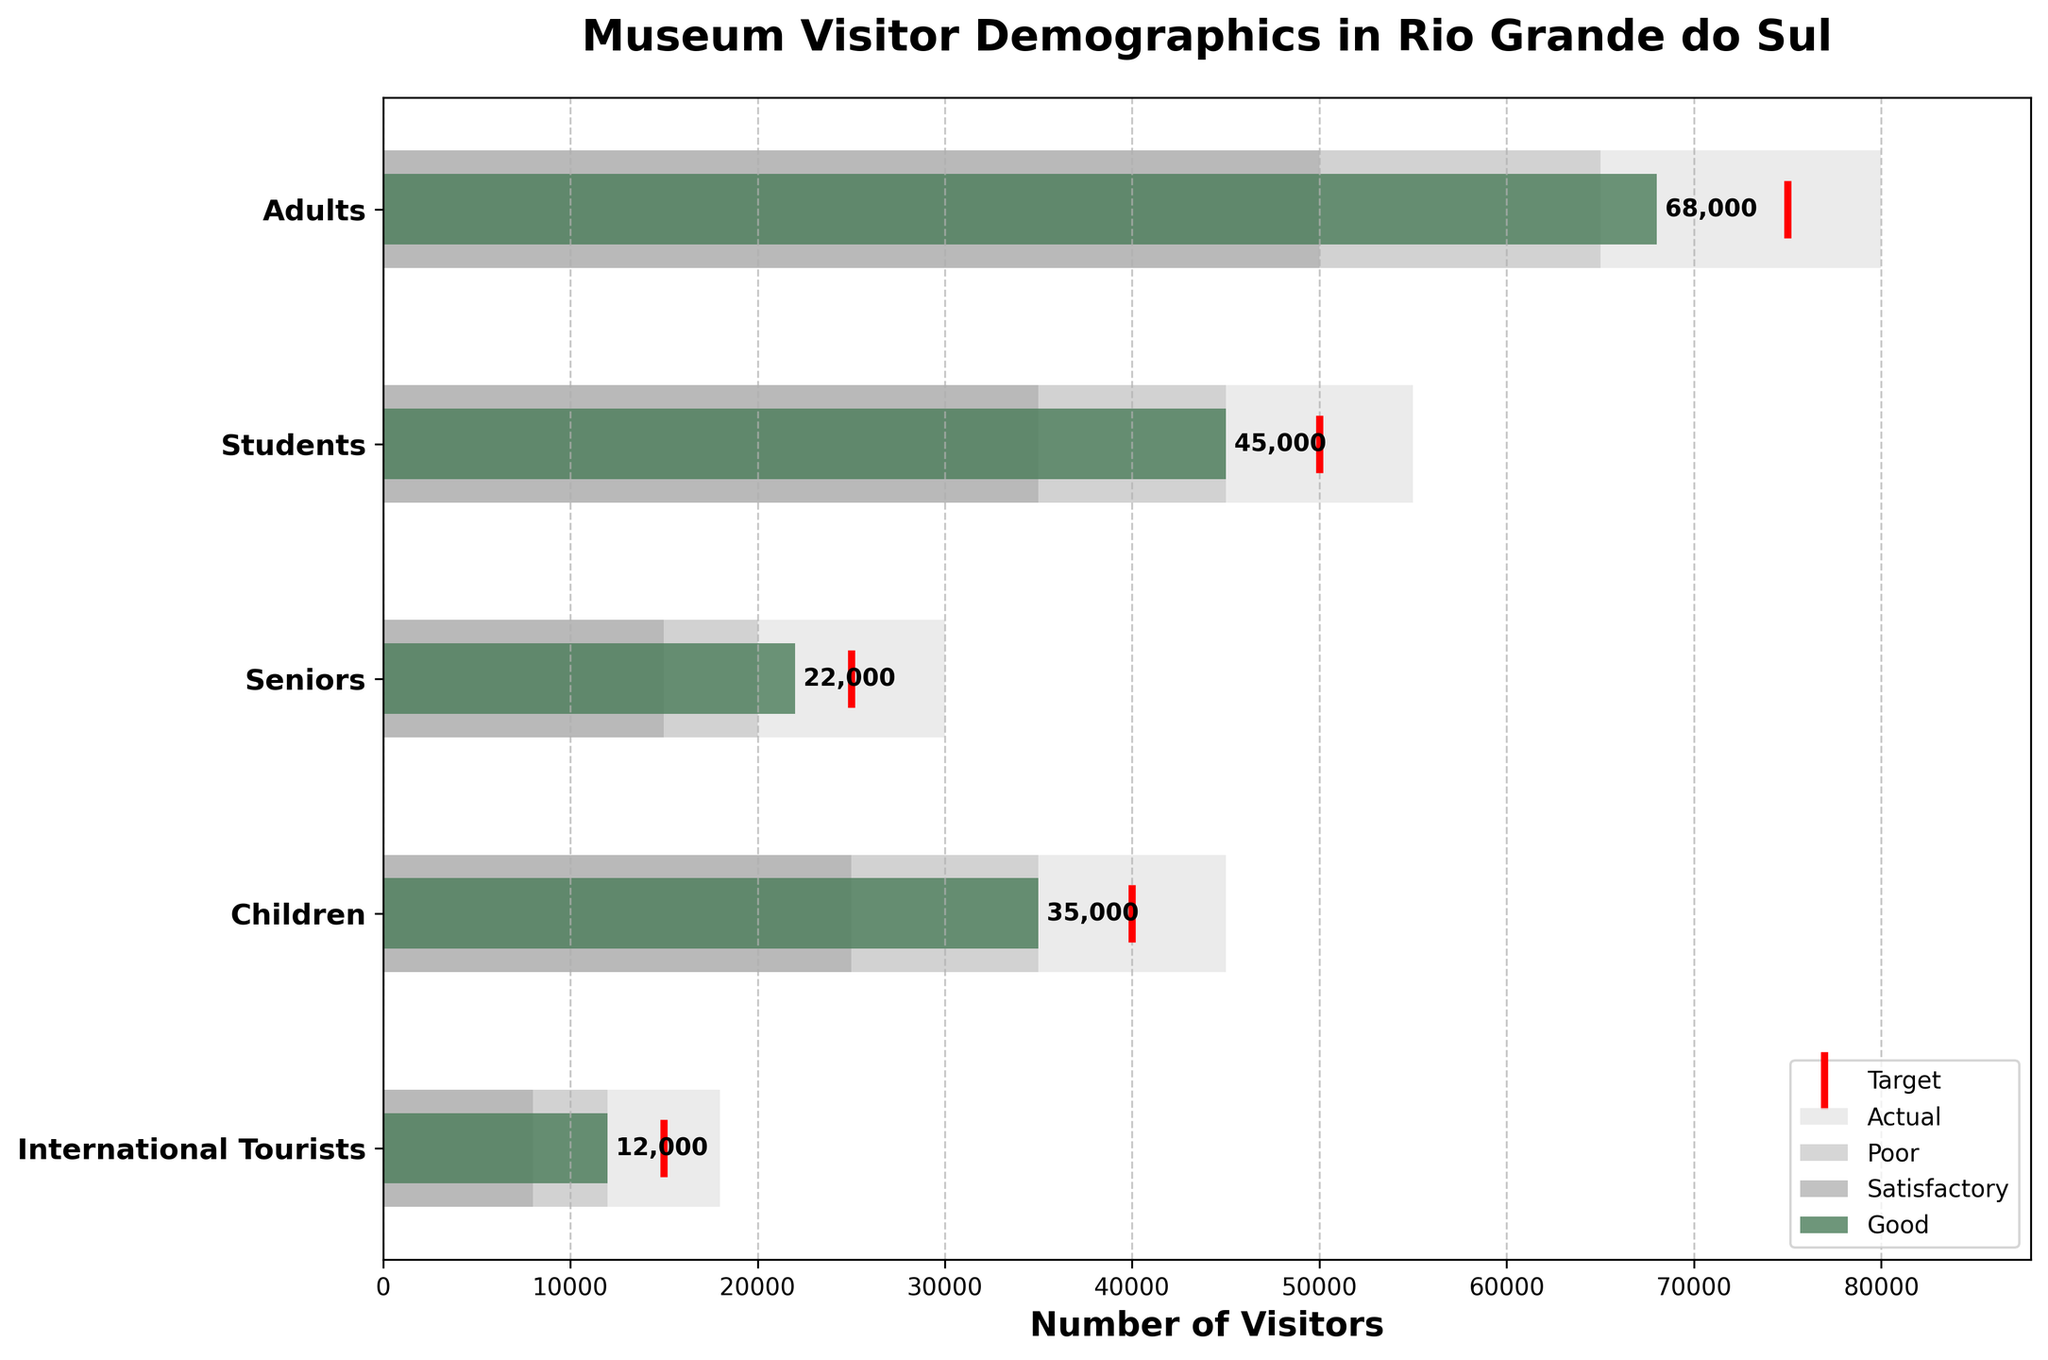What are the categories listed on the y-axis? The categories listed on the y-axis are "Adults", "Students", "Seniors", "Children", and "International Tourists".
Answer: "Adults", "Students", "Seniors", "Children", "International Tourists" Which category has the highest actual number of visitors? The highest actual number of visitors is represented by the longest green bar.
Answer: Adults Is there any category where the actual number of visitors exactly meets the target? The actual number meets the target when the end of the green bar aligns with the red line.
Answer: No How many visitors are targeted for Seniors? The target number of visitors is marked with a red line on the bar corresponding to Seniors.
Answer: 25000 What is the difference between the target and actual visitors for Children? Subtract the actual number of visitors for Children (35000) from the target number (40000).
Answer: 5000 Which category has the poorest performance against its target? The poorest performance is where the actual bar (green bar) is the shortest in comparison to its target marked by the red line.
Answer: International Tourists How many categories have their actual visitor numbers in the "Good" performance range? The "Good" performance range is the third bar range from the left. Count the categories where the green bar extends into this range.
Answer: 2 What is the average actual number of visitors for all categories combined? Add all the actual numbers of visitors together and then divide by the number of categories: (68000 + 45000 + 22000 + 35000 + 12000) / 5.
Answer: 36400 Compare the actual numbers between Adults and Students. Which one is greater? Compare the length of the green bars for Adults and Students.
Answer: Adults What are the ranges of visitors for the category of Students? The ranges are visually represented by the three different shaded bars.
Answer: Poor: 35000, Satisfactory: 45000, Good: 55000 